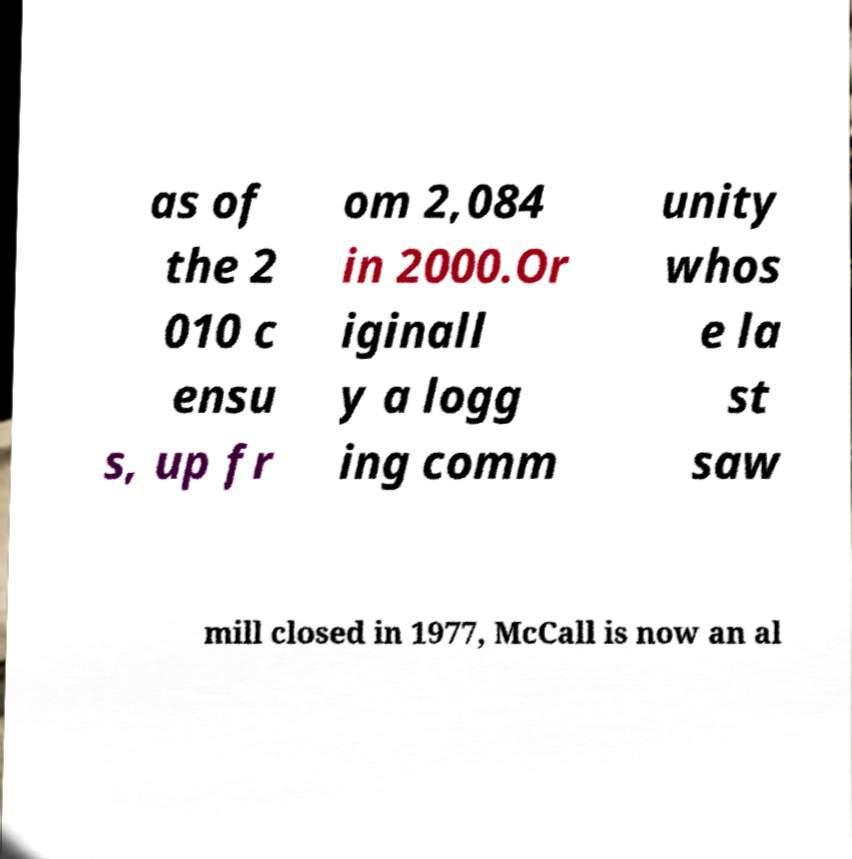There's text embedded in this image that I need extracted. Can you transcribe it verbatim? as of the 2 010 c ensu s, up fr om 2,084 in 2000.Or iginall y a logg ing comm unity whos e la st saw mill closed in 1977, McCall is now an al 